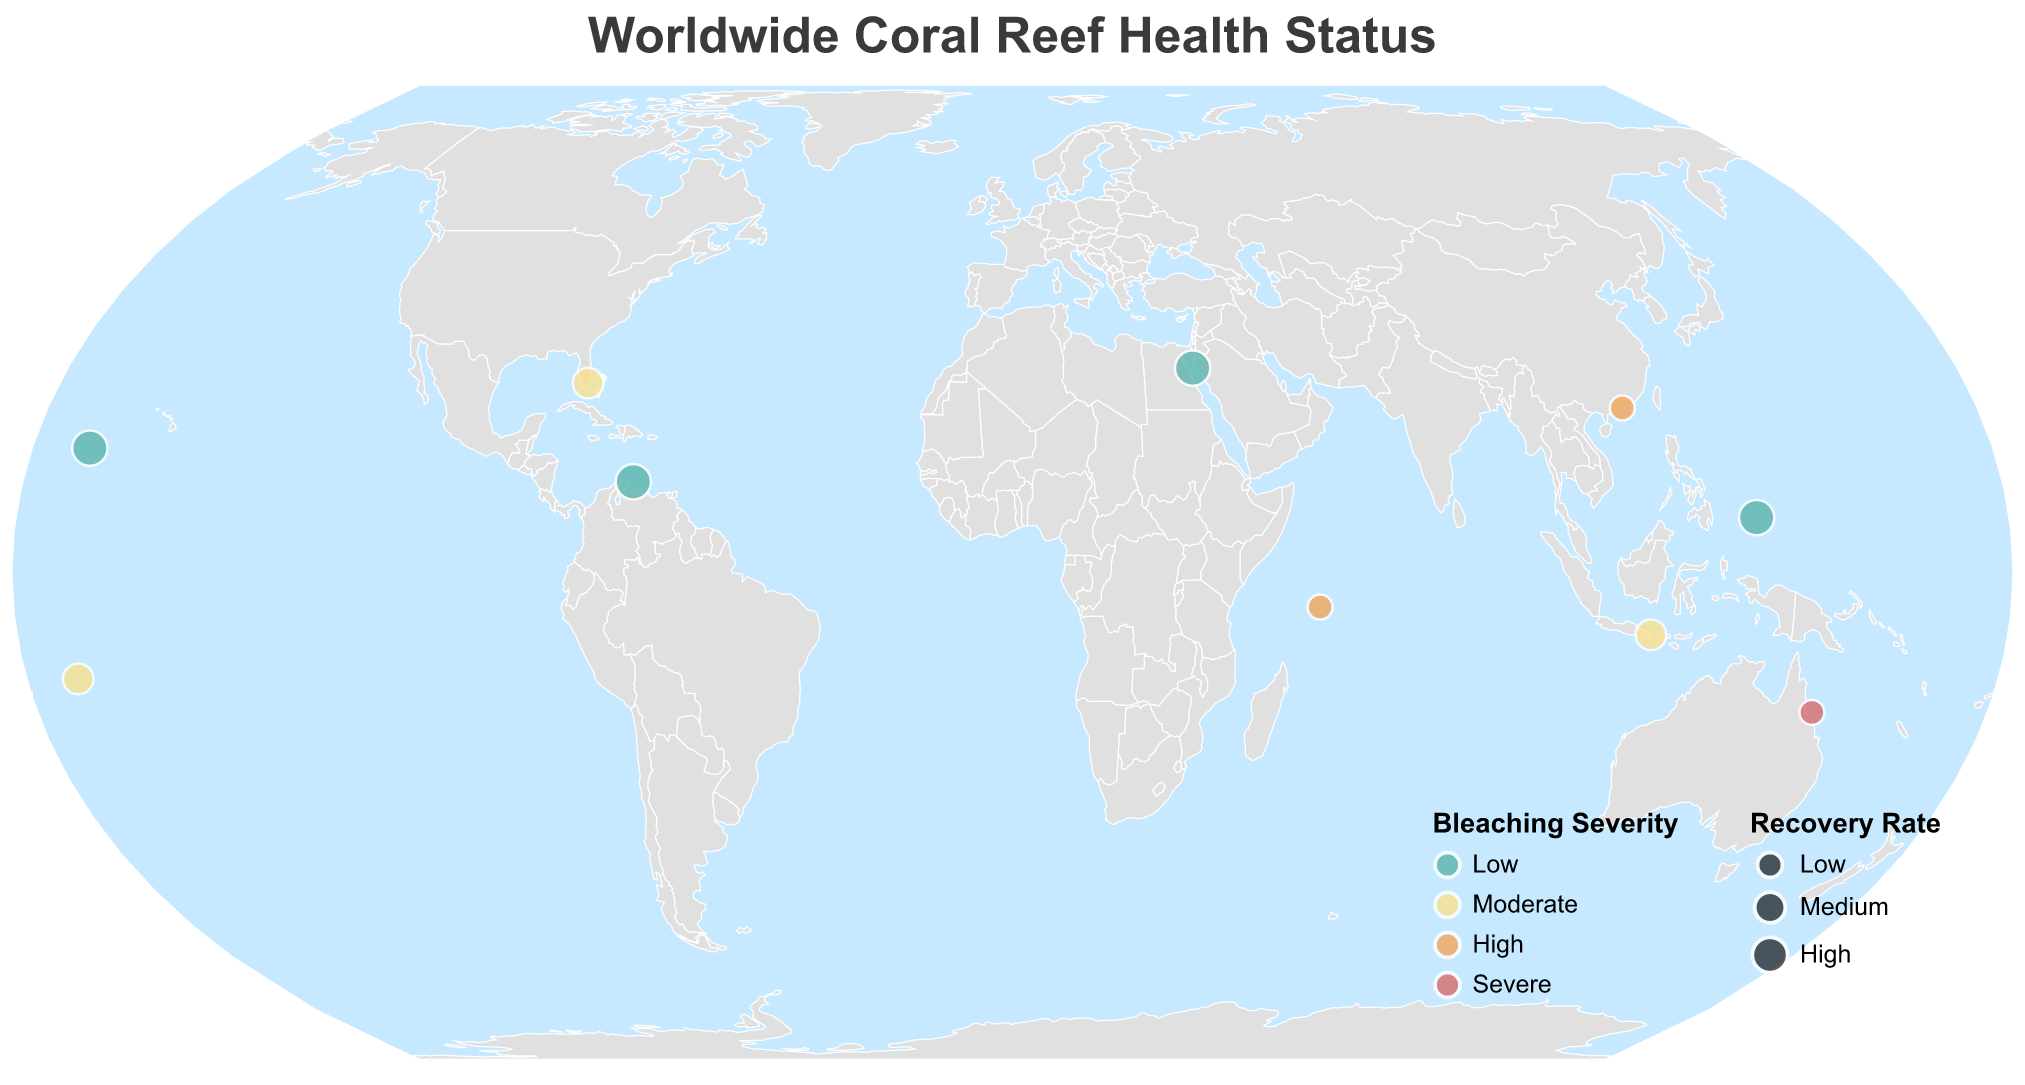What is the overall title of the figure? The title is shown at the top center of the figure, and it is "Worldwide Coral Reef Health Status".
Answer: Worldwide Coral Reef Health Status How many locations are represented in the figure? By counting the number of data points or locations on the chart, we find there are 10 distinct locations.
Answer: 10 Which location has the most severe bleaching severity? By looking at the color legend, red represents severe bleaching conditions. The location marked in red is the Great Barrier Reef.
Answer: Great Barrier Reef Which location has both high bleaching severity and low recovery rate? By cross-referencing the color (high severity - orange) and the size of the circle (low recovery rate - smallest), the location is Seychelles.
Answer: Seychelles How does the bleaching severity of Florida Keys compare to that of Bali? Looking at the color shades, Florida Keys is marked with a yellow/medium shade for moderate severity, and Bali also has a similar yellow/medium shade, indicating they have the same bleaching severity.
Answer: Equal Which location has the highest recovery rate? The largest circles represent locations with high recovery rates. Multiple locations have large circles, names of them include Kingman Reef, Palau, Bonaire, and Red Sea.
Answer: Kingman Reef, Palau, Bonaire, Red Sea What is the dominant coral species in Palau? Hovering over or checking the tooltip associated with the Palau's data point reveals that "Heliopora coerulea" is the dominant species.
Answer: Heliopora coerulea Which location(s) exhibit low bleaching severity and high recovery rates? We look for locations marked with the color representing low severity (green) and the largest circle size (high recovery rate): Kingman Reef, Palau, Bonaire, and Red Sea.
Answer: Kingman Reef, Palau, Bonaire, Red Sea In which regions can high bleaching severity be observed? Regions with high bleaching severity are marked with orange, which include Seychelles and Hong Kong.
Answer: Seychelles, Hong Kong How do the recovery rates compare between the Great Barrier Reef and American Samoa? The smaller circle represents the lower recovery rate. The Great Barrier Reef displays a smaller circle (low recovery rate), while American Samoa shows a medium-sized circle (medium recovery rate), so American Samoa has a higher recovery rate.
Answer: American Samoa has a higher recovery rate than Great Barrier Reef 